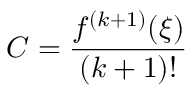Convert formula to latex. <formula><loc_0><loc_0><loc_500><loc_500>C = { \frac { f ^ { ( k + 1 ) } ( \xi ) } { ( k + 1 ) ! } }</formula> 